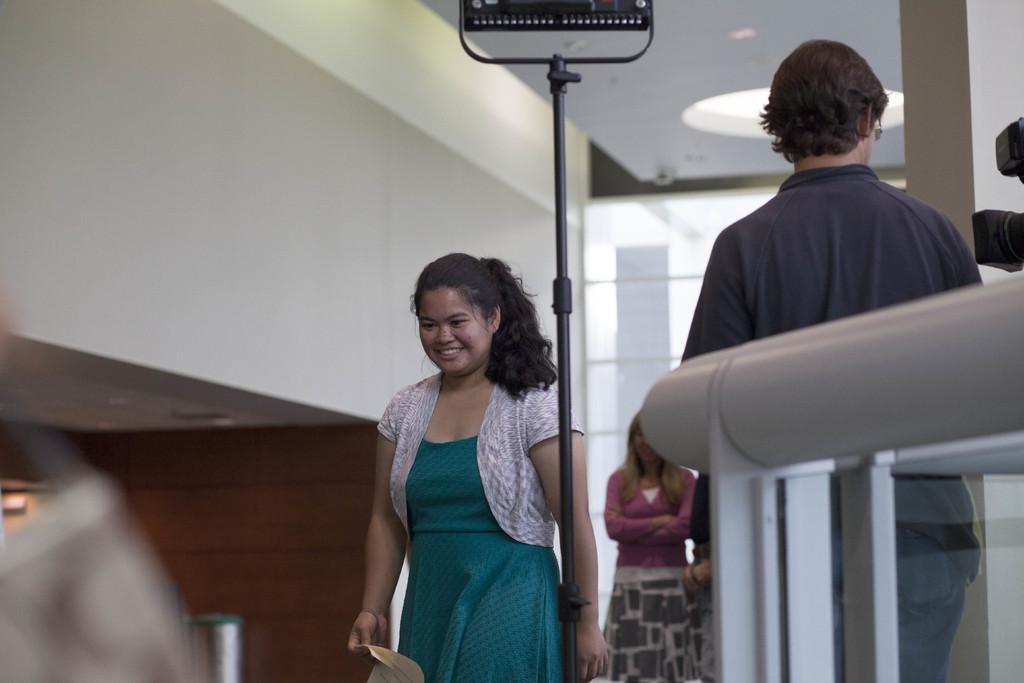Can you describe this image briefly? In this image we can see a group of people standing. In that a woman is holding a paper. We can also see a light with a stand, a camera, poles of a fence, a wall and a roof with some ceiling lights. 